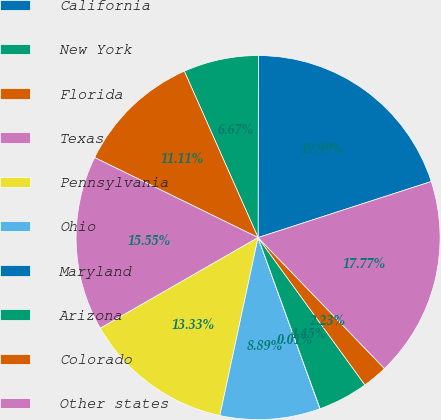<chart> <loc_0><loc_0><loc_500><loc_500><pie_chart><fcel>California<fcel>New York<fcel>Florida<fcel>Texas<fcel>Pennsylvania<fcel>Ohio<fcel>Maryland<fcel>Arizona<fcel>Colorado<fcel>Other states<nl><fcel>19.99%<fcel>6.67%<fcel>11.11%<fcel>15.55%<fcel>13.33%<fcel>8.89%<fcel>0.01%<fcel>4.45%<fcel>2.23%<fcel>17.77%<nl></chart> 